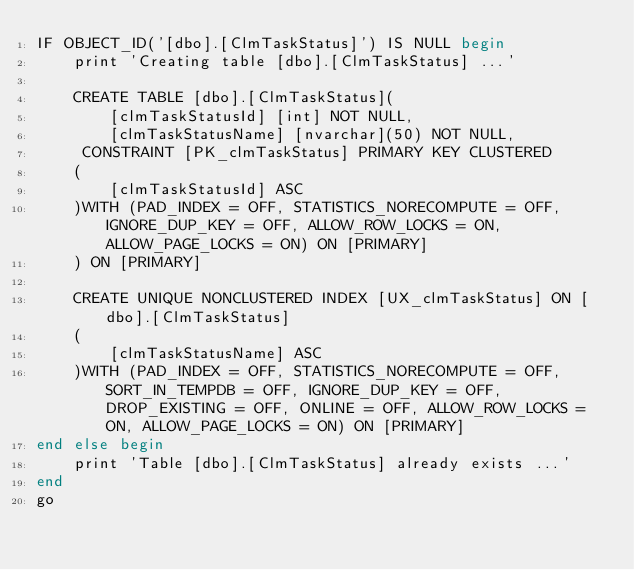<code> <loc_0><loc_0><loc_500><loc_500><_SQL_>IF OBJECT_ID('[dbo].[ClmTaskStatus]') IS NULL begin
	print 'Creating table [dbo].[ClmTaskStatus] ...'

	CREATE TABLE [dbo].[ClmTaskStatus](
		[clmTaskStatusId] [int] NOT NULL,
		[clmTaskStatusName] [nvarchar](50) NOT NULL,
	 CONSTRAINT [PK_clmTaskStatus] PRIMARY KEY CLUSTERED 
	(
		[clmTaskStatusId] ASC
	)WITH (PAD_INDEX = OFF, STATISTICS_NORECOMPUTE = OFF, IGNORE_DUP_KEY = OFF, ALLOW_ROW_LOCKS = ON, ALLOW_PAGE_LOCKS = ON) ON [PRIMARY]
	) ON [PRIMARY]

	CREATE UNIQUE NONCLUSTERED INDEX [UX_clmTaskStatus] ON [dbo].[ClmTaskStatus]
	(
		[clmTaskStatusName] ASC
	)WITH (PAD_INDEX = OFF, STATISTICS_NORECOMPUTE = OFF, SORT_IN_TEMPDB = OFF, IGNORE_DUP_KEY = OFF, DROP_EXISTING = OFF, ONLINE = OFF, ALLOW_ROW_LOCKS = ON, ALLOW_PAGE_LOCKS = ON) ON [PRIMARY]
end else begin
	print 'Table [dbo].[ClmTaskStatus] already exists ...'
end
go


</code> 